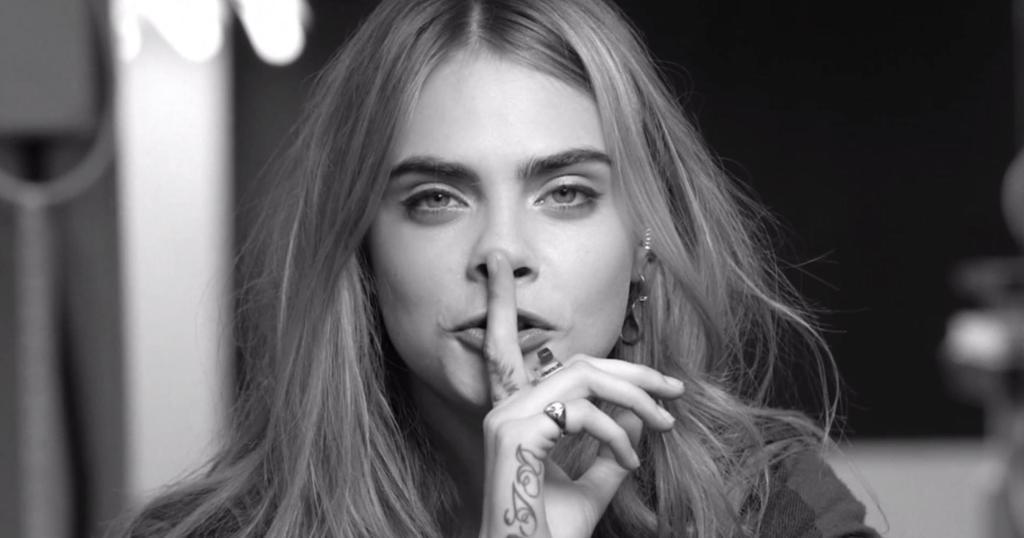Can you describe this image briefly? It is the black and white image in which there is a girl in the middle who kept her finger on her mouth. In the background it is blur. 